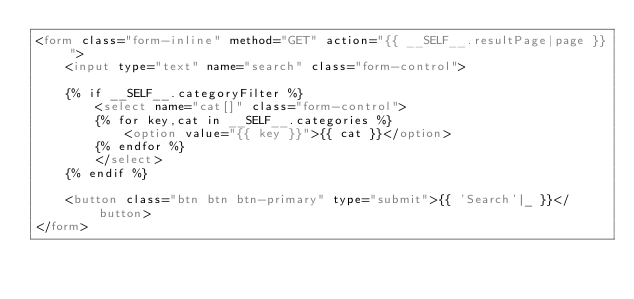Convert code to text. <code><loc_0><loc_0><loc_500><loc_500><_HTML_><form class="form-inline" method="GET" action="{{ __SELF__.resultPage|page }}">
    <input type="text" name="search" class="form-control">

    {% if __SELF__.categoryFilter %}
        <select name="cat[]" class="form-control">
        {% for key,cat in __SELF__.categories %}
            <option value="{{ key }}">{{ cat }}</option>
        {% endfor %}
        </select>
    {% endif %}

    <button class="btn btn btn-primary" type="submit">{{ 'Search'|_ }}</button>
</form></code> 